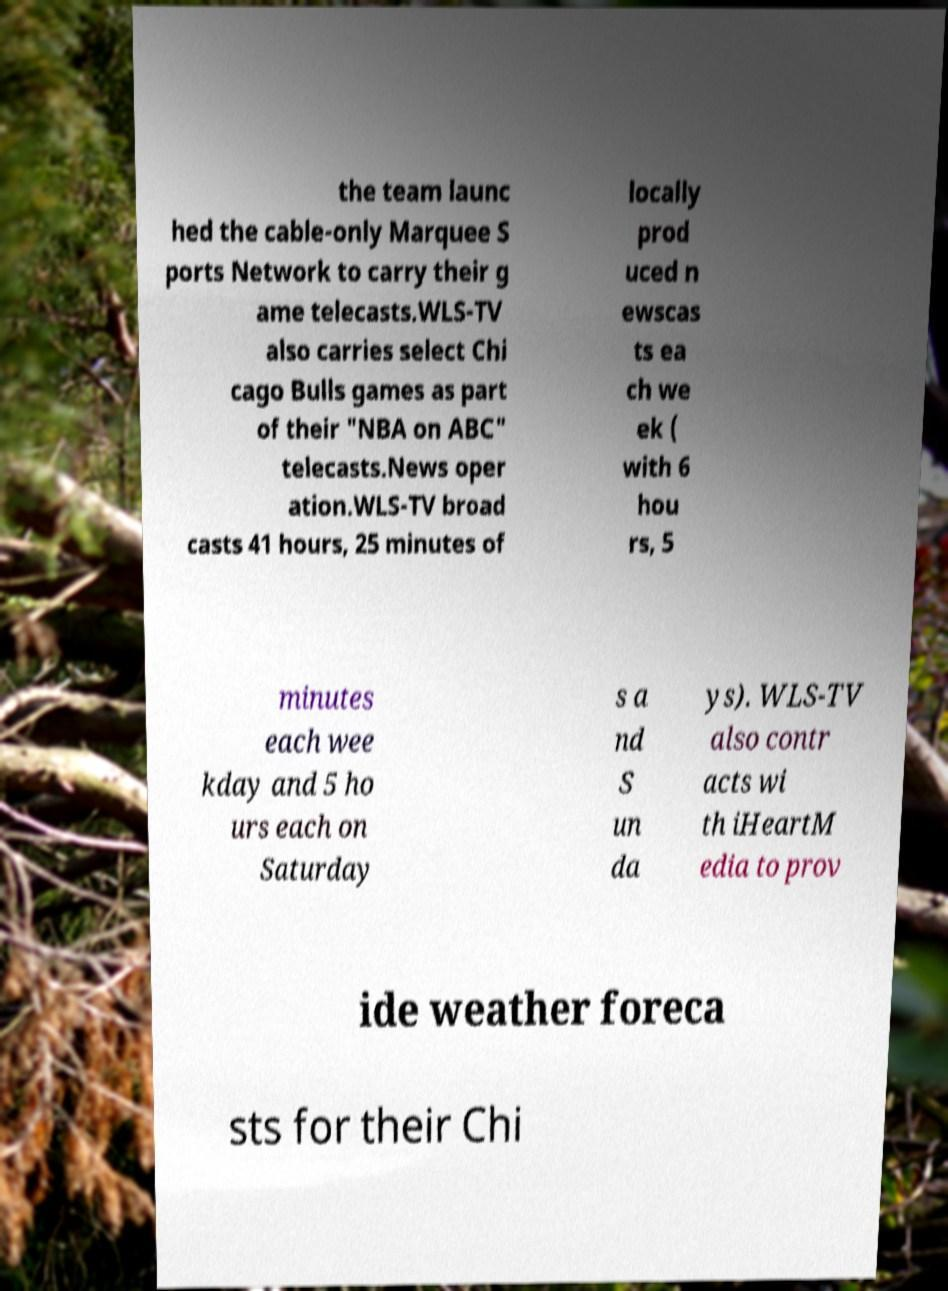Could you extract and type out the text from this image? the team launc hed the cable-only Marquee S ports Network to carry their g ame telecasts.WLS-TV also carries select Chi cago Bulls games as part of their "NBA on ABC" telecasts.News oper ation.WLS-TV broad casts 41 hours, 25 minutes of locally prod uced n ewscas ts ea ch we ek ( with 6 hou rs, 5 minutes each wee kday and 5 ho urs each on Saturday s a nd S un da ys). WLS-TV also contr acts wi th iHeartM edia to prov ide weather foreca sts for their Chi 